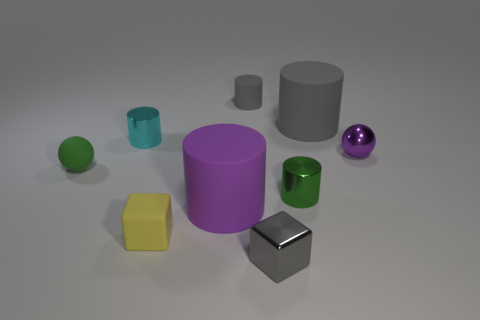What number of small gray things are in front of the gray cylinder right of the thing in front of the small matte cube?
Offer a terse response. 1. What number of other objects are the same material as the small purple sphere?
Offer a very short reply. 3. What material is the gray cube that is the same size as the cyan thing?
Offer a very short reply. Metal. There is a small rubber object behind the shiny ball; is it the same color as the large cylinder behind the cyan metallic cylinder?
Provide a succinct answer. Yes. Are there any tiny purple metallic objects that have the same shape as the small green rubber object?
Your answer should be very brief. Yes. The purple metal thing that is the same size as the cyan cylinder is what shape?
Offer a very short reply. Sphere. How many things are the same color as the metal ball?
Ensure brevity in your answer.  1. There is a purple object left of the small purple object; how big is it?
Your answer should be very brief. Large. What number of shiny spheres are the same size as the gray metal object?
Make the answer very short. 1. What color is the tiny cylinder that is made of the same material as the big gray object?
Your response must be concise. Gray. 